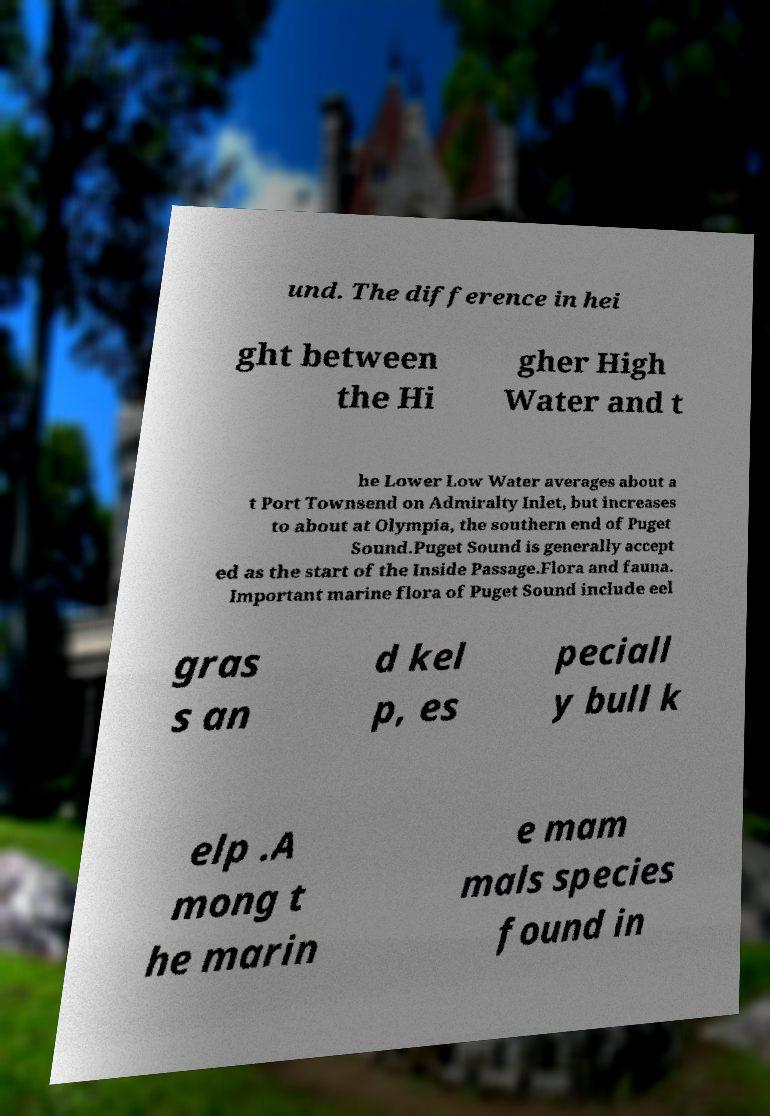Could you extract and type out the text from this image? und. The difference in hei ght between the Hi gher High Water and t he Lower Low Water averages about a t Port Townsend on Admiralty Inlet, but increases to about at Olympia, the southern end of Puget Sound.Puget Sound is generally accept ed as the start of the Inside Passage.Flora and fauna. Important marine flora of Puget Sound include eel gras s an d kel p, es peciall y bull k elp .A mong t he marin e mam mals species found in 